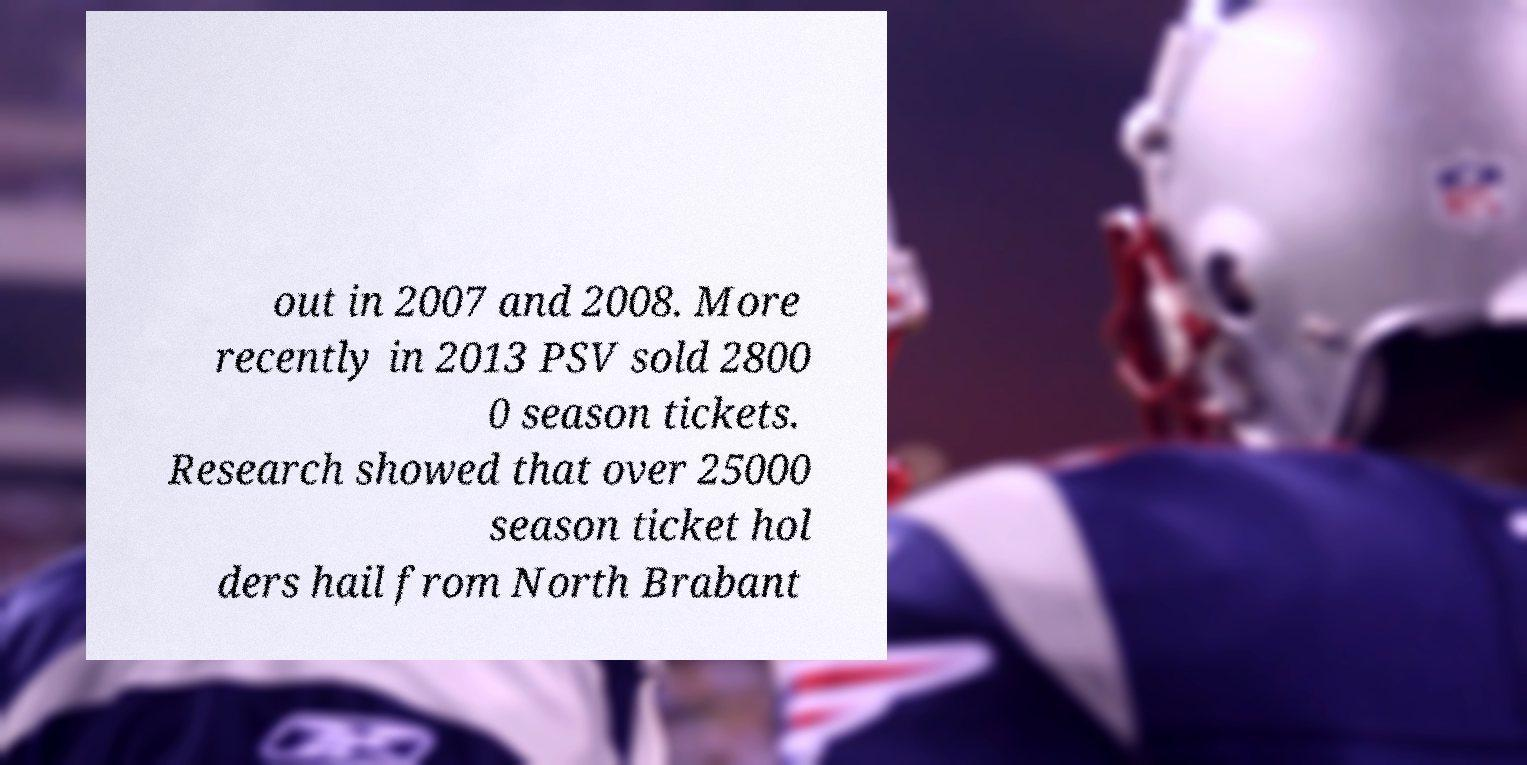Could you assist in decoding the text presented in this image and type it out clearly? out in 2007 and 2008. More recently in 2013 PSV sold 2800 0 season tickets. Research showed that over 25000 season ticket hol ders hail from North Brabant 